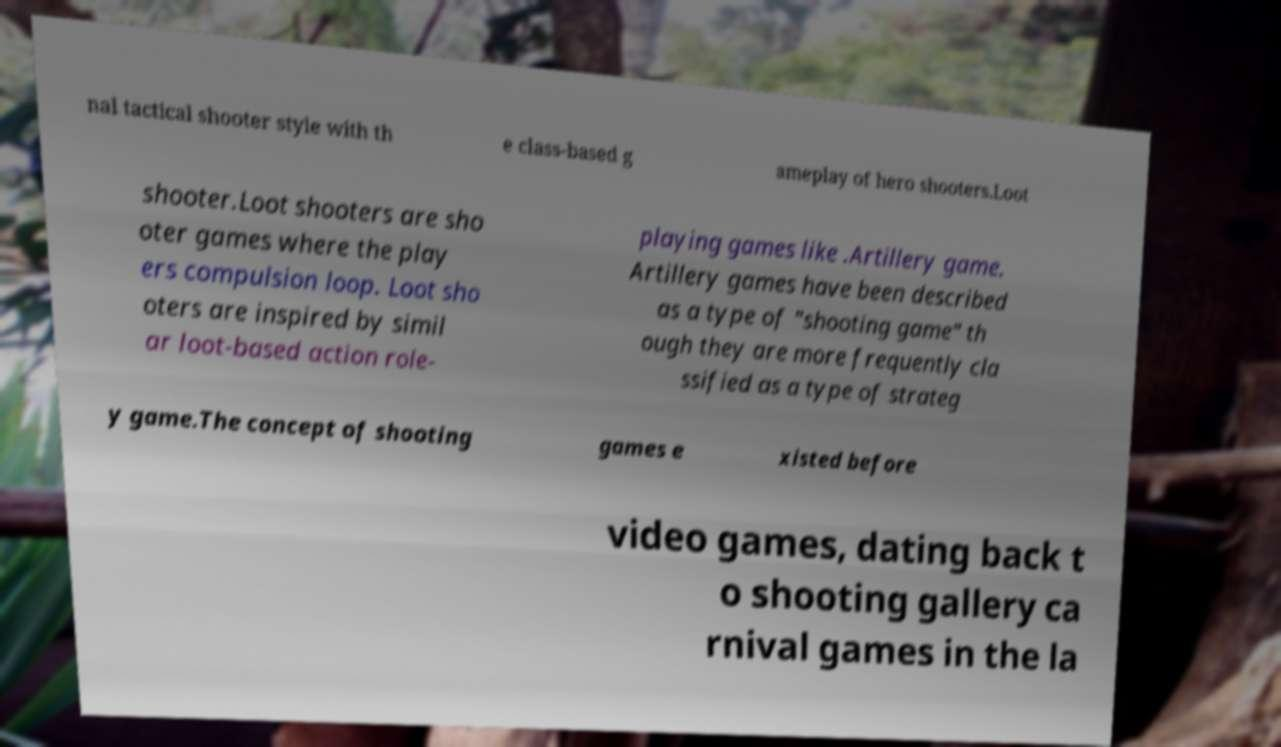I need the written content from this picture converted into text. Can you do that? nal tactical shooter style with th e class-based g ameplay of hero shooters.Loot shooter.Loot shooters are sho oter games where the play ers compulsion loop. Loot sho oters are inspired by simil ar loot-based action role- playing games like .Artillery game. Artillery games have been described as a type of "shooting game" th ough they are more frequently cla ssified as a type of strateg y game.The concept of shooting games e xisted before video games, dating back t o shooting gallery ca rnival games in the la 